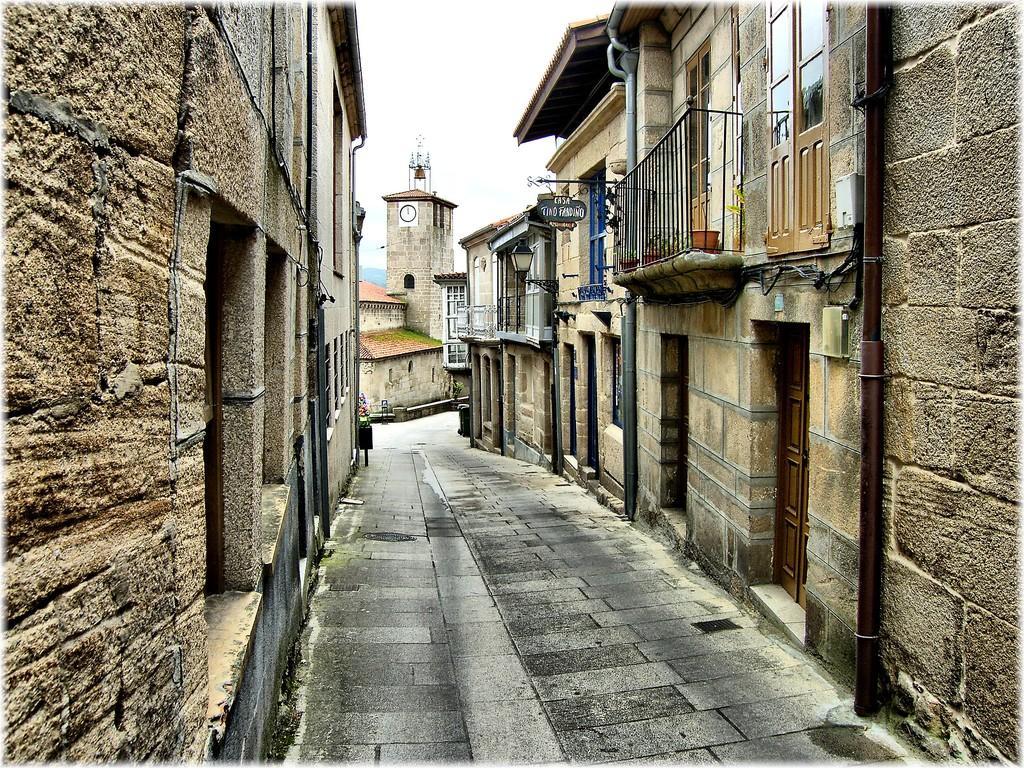Can you describe this image briefly? In this picture I can see the clock tower, buildings and shed. In the back I can see the road. At the top I can see the sky and clouds. On the right I can see the windows, doors, water pipe and feeling. 